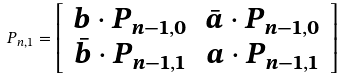Convert formula to latex. <formula><loc_0><loc_0><loc_500><loc_500>P _ { n , 1 } = \left [ \begin{array} { c c } b \cdot P _ { n - 1 , 0 } & \bar { a } \cdot P _ { n - 1 , 0 } \\ \bar { b } \cdot P _ { n - 1 , 1 } & a \cdot P _ { n - 1 , 1 } \end{array} \right ]</formula> 